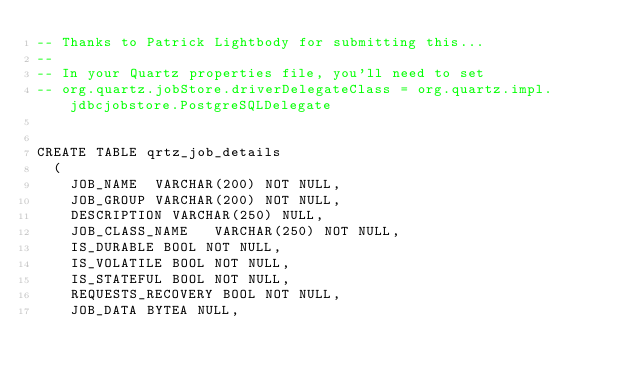Convert code to text. <code><loc_0><loc_0><loc_500><loc_500><_SQL_>-- Thanks to Patrick Lightbody for submitting this...
--
-- In your Quartz properties file, you'll need to set 
-- org.quartz.jobStore.driverDelegateClass = org.quartz.impl.jdbcjobstore.PostgreSQLDelegate


CREATE TABLE qrtz_job_details
  (
    JOB_NAME  VARCHAR(200) NOT NULL,
    JOB_GROUP VARCHAR(200) NOT NULL,
    DESCRIPTION VARCHAR(250) NULL,
    JOB_CLASS_NAME   VARCHAR(250) NOT NULL, 
    IS_DURABLE BOOL NOT NULL,
    IS_VOLATILE BOOL NOT NULL,
    IS_STATEFUL BOOL NOT NULL,
    REQUESTS_RECOVERY BOOL NOT NULL,
    JOB_DATA BYTEA NULL,</code> 